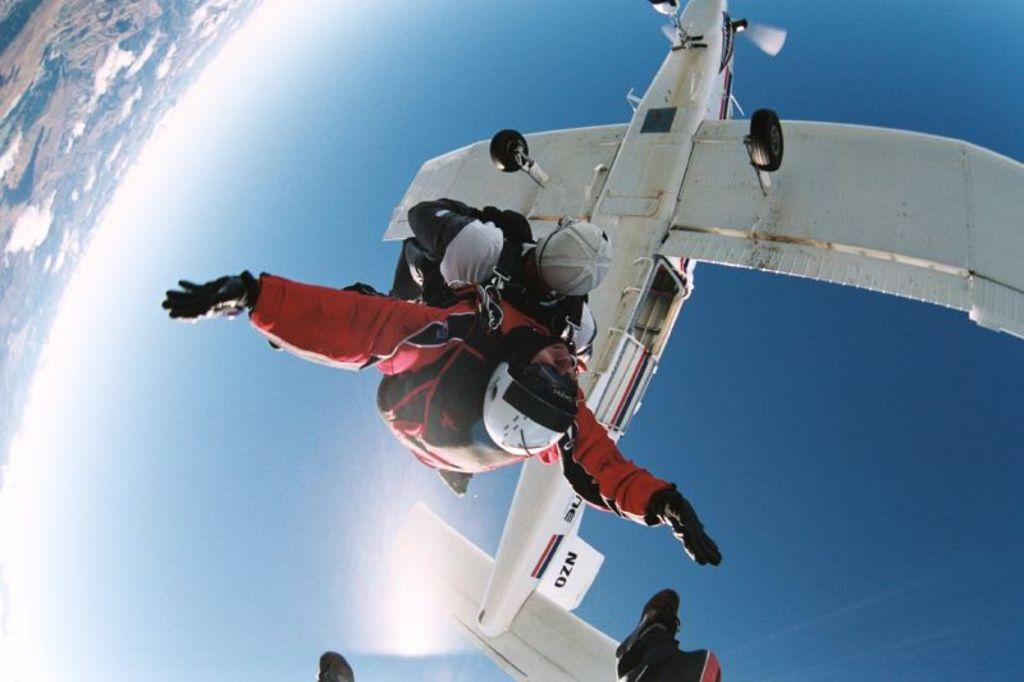What is the main subject of the picture? The main subject of the picture is an airplane. What are the people in the image doing? There are three people flying in the air in the image. Can you describe the third person's appearance? The third person's picture is not clear, so it's difficult to describe their appearance. What can be seen on the left side of the image? There is a land surface on the left side of the image. Where is the sink located in the image? There is no sink present in the image. What is the altitude of the airplane in the image? The altitude of the airplane cannot be determined from the image alone. Is there a rifle visible in the image? There is no rifle present in the image. 